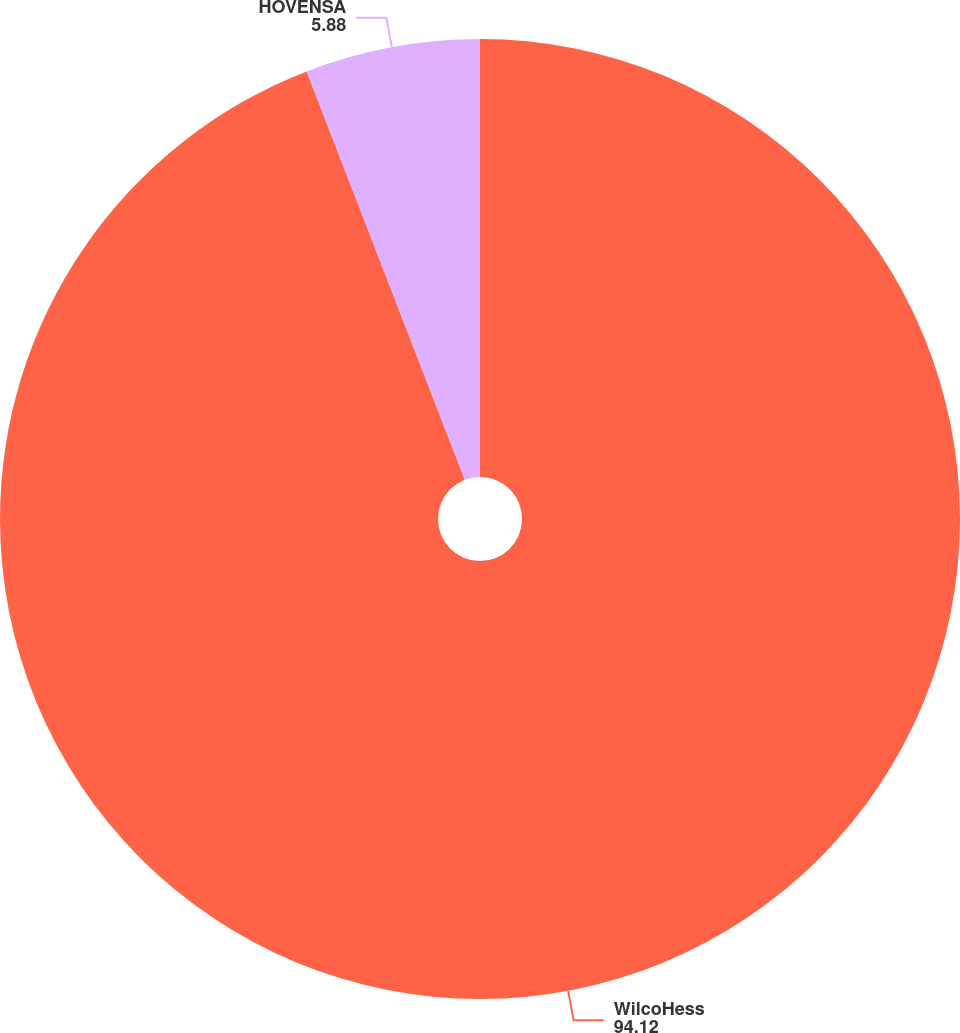Convert chart. <chart><loc_0><loc_0><loc_500><loc_500><pie_chart><fcel>WilcoHess<fcel>HOVENSA<nl><fcel>94.12%<fcel>5.88%<nl></chart> 